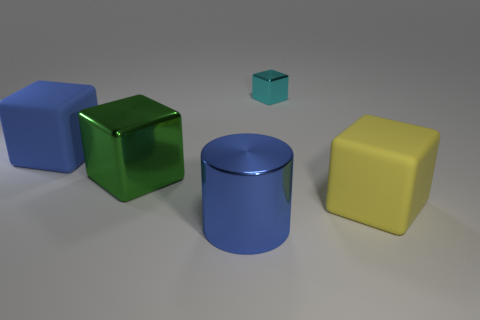There is a rubber thing that is the same color as the big metallic cylinder; what is its shape?
Give a very brief answer. Cube. What is the thing that is both behind the green metallic block and right of the blue metal cylinder made of?
Your answer should be compact. Metal. What color is the big matte object that is to the right of the blue object that is to the right of the rubber block that is left of the large green cube?
Your answer should be compact. Yellow. There is a cylinder that is the same size as the yellow object; what is its color?
Keep it short and to the point. Blue. There is a shiny cylinder; does it have the same color as the big matte cube that is left of the cyan thing?
Provide a short and direct response. Yes. What is the blue thing that is left of the large metal object in front of the large green object made of?
Keep it short and to the point. Rubber. What number of objects are behind the large yellow object and on the left side of the tiny cyan cube?
Your response must be concise. 2. How many other things are there of the same size as the metal cylinder?
Your answer should be very brief. 3. Does the object right of the small object have the same shape as the large metallic thing that is behind the blue metallic thing?
Keep it short and to the point. Yes. Are there any metal cylinders right of the small cyan object?
Keep it short and to the point. No. 